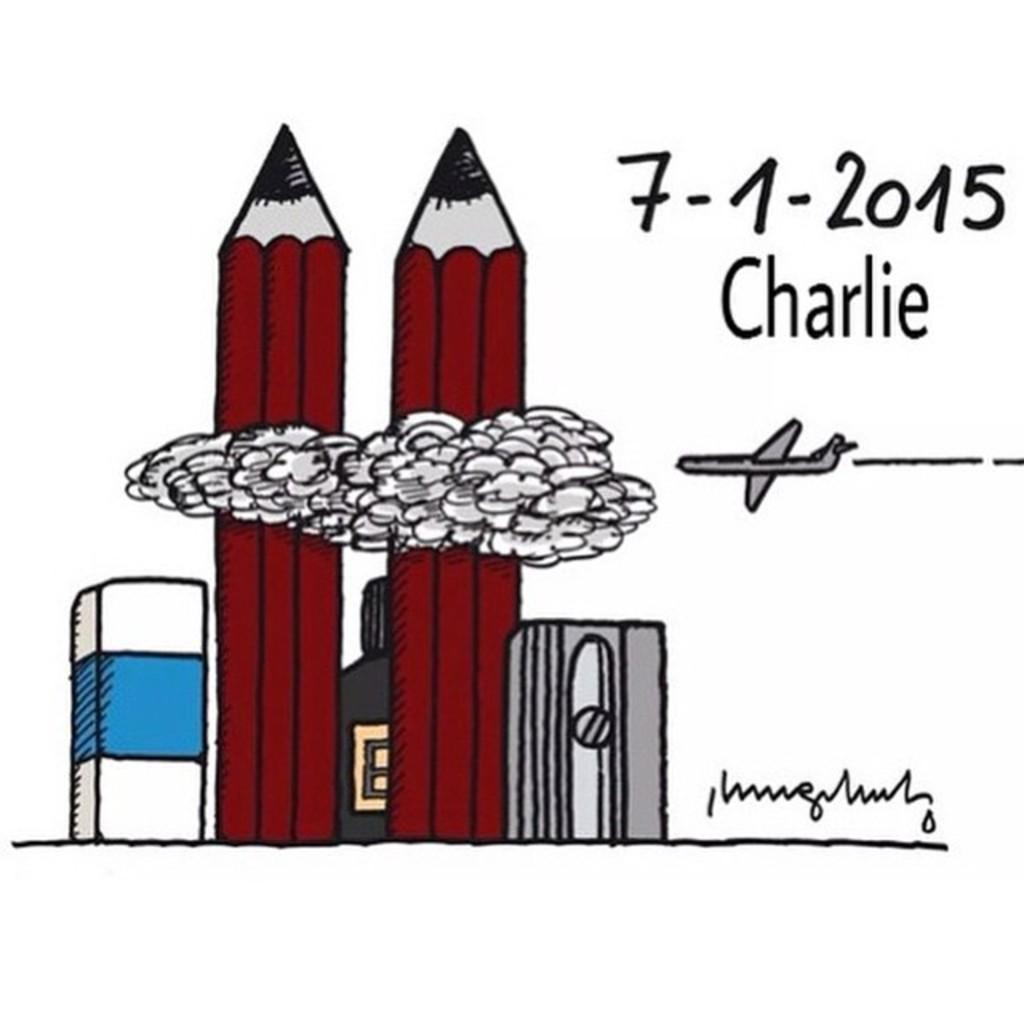What is being drawn in the image? There is a drawing of a pencil, an eraser, a sharpener, and a flying jet in the image. What can be seen in the sky in the image? There are clouds visible in the image. Is there any text present in the image? Yes, there is text present in the image. What type of orange is being used to draw the jet in the image? There is no orange present in the image; it is a drawing of a jet, not an actual orange. 